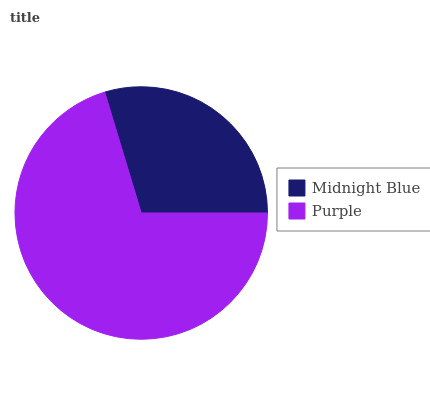Is Midnight Blue the minimum?
Answer yes or no. Yes. Is Purple the maximum?
Answer yes or no. Yes. Is Purple the minimum?
Answer yes or no. No. Is Purple greater than Midnight Blue?
Answer yes or no. Yes. Is Midnight Blue less than Purple?
Answer yes or no. Yes. Is Midnight Blue greater than Purple?
Answer yes or no. No. Is Purple less than Midnight Blue?
Answer yes or no. No. Is Purple the high median?
Answer yes or no. Yes. Is Midnight Blue the low median?
Answer yes or no. Yes. Is Midnight Blue the high median?
Answer yes or no. No. Is Purple the low median?
Answer yes or no. No. 